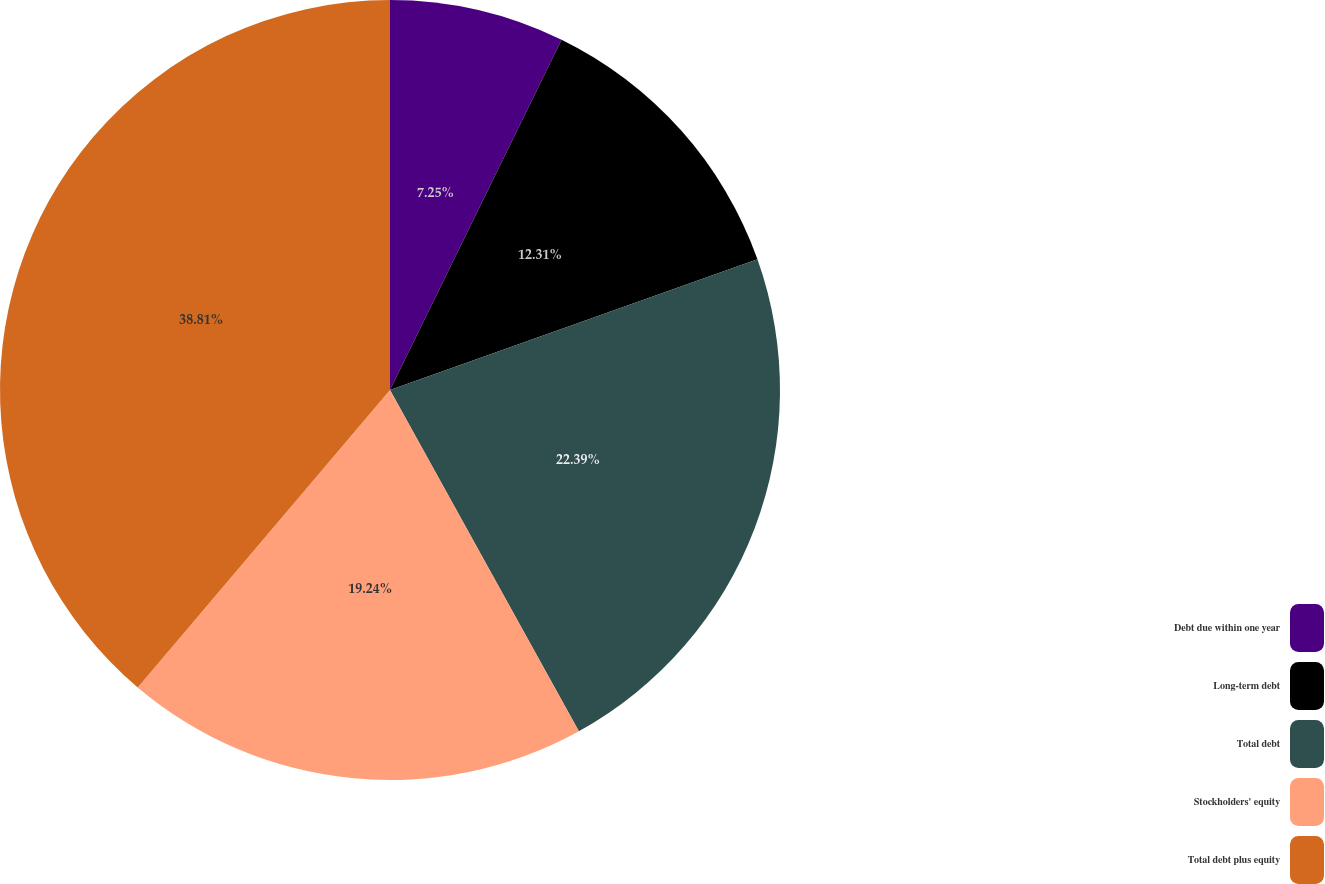Convert chart. <chart><loc_0><loc_0><loc_500><loc_500><pie_chart><fcel>Debt due within one year<fcel>Long-term debt<fcel>Total debt<fcel>Stockholders' equity<fcel>Total debt plus equity<nl><fcel>7.25%<fcel>12.31%<fcel>22.39%<fcel>19.24%<fcel>38.8%<nl></chart> 